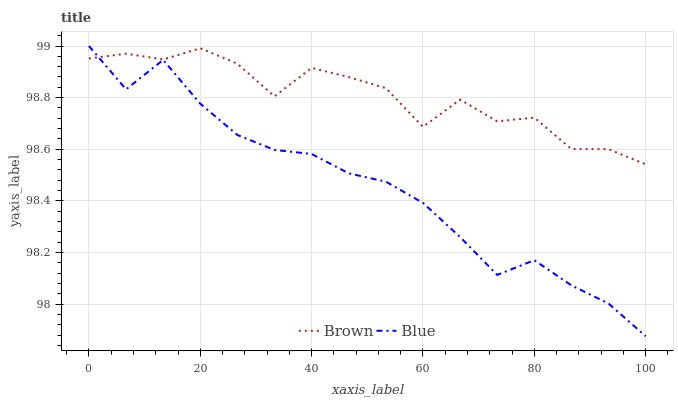Does Blue have the minimum area under the curve?
Answer yes or no. Yes. Does Brown have the maximum area under the curve?
Answer yes or no. Yes. Does Brown have the minimum area under the curve?
Answer yes or no. No. Is Blue the smoothest?
Answer yes or no. Yes. Is Brown the roughest?
Answer yes or no. Yes. Is Brown the smoothest?
Answer yes or no. No. Does Blue have the lowest value?
Answer yes or no. Yes. Does Brown have the lowest value?
Answer yes or no. No. Does Blue have the highest value?
Answer yes or no. Yes. Does Brown have the highest value?
Answer yes or no. No. Does Blue intersect Brown?
Answer yes or no. Yes. Is Blue less than Brown?
Answer yes or no. No. Is Blue greater than Brown?
Answer yes or no. No. 